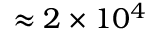<formula> <loc_0><loc_0><loc_500><loc_500>\approx 2 \times 1 0 ^ { 4 }</formula> 